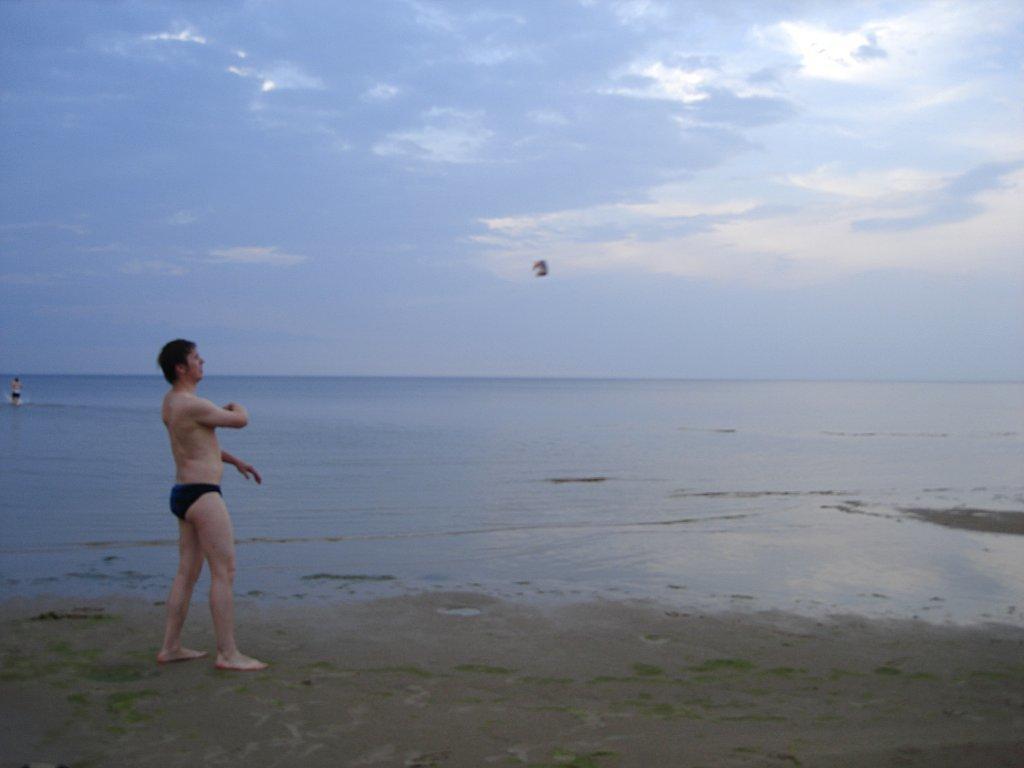Can you describe this image briefly? In the picture I can see a person is standing on the ground. In the background I can see a person is in the water and the sky. 